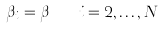<formula> <loc_0><loc_0><loc_500><loc_500>\beta _ { i } = \beta \quad i = 2 , \dots , N</formula> 